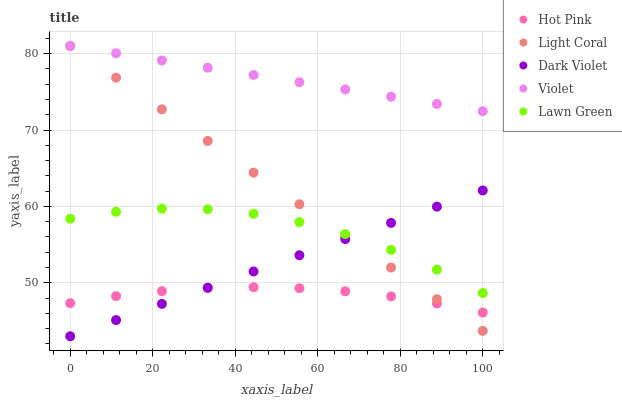Does Hot Pink have the minimum area under the curve?
Answer yes or no. Yes. Does Violet have the maximum area under the curve?
Answer yes or no. Yes. Does Lawn Green have the minimum area under the curve?
Answer yes or no. No. Does Lawn Green have the maximum area under the curve?
Answer yes or no. No. Is Dark Violet the smoothest?
Answer yes or no. Yes. Is Lawn Green the roughest?
Answer yes or no. Yes. Is Hot Pink the smoothest?
Answer yes or no. No. Is Hot Pink the roughest?
Answer yes or no. No. Does Dark Violet have the lowest value?
Answer yes or no. Yes. Does Lawn Green have the lowest value?
Answer yes or no. No. Does Violet have the highest value?
Answer yes or no. Yes. Does Lawn Green have the highest value?
Answer yes or no. No. Is Hot Pink less than Violet?
Answer yes or no. Yes. Is Violet greater than Hot Pink?
Answer yes or no. Yes. Does Light Coral intersect Violet?
Answer yes or no. Yes. Is Light Coral less than Violet?
Answer yes or no. No. Is Light Coral greater than Violet?
Answer yes or no. No. Does Hot Pink intersect Violet?
Answer yes or no. No. 